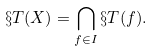<formula> <loc_0><loc_0><loc_500><loc_500>\S T ( X ) = \bigcap _ { f \in I } \S T ( f ) .</formula> 